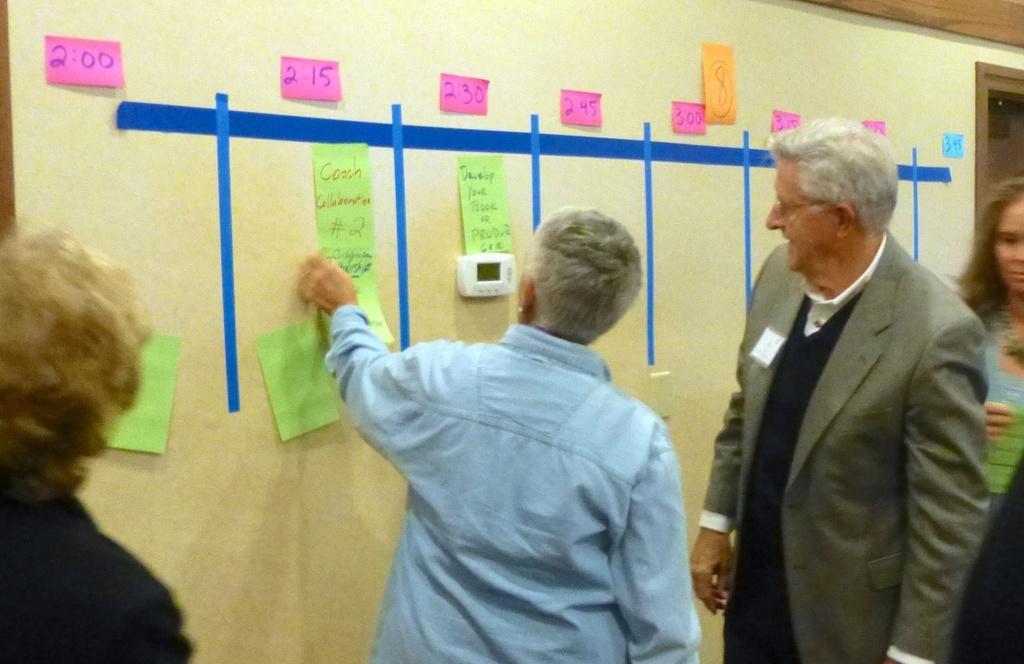Could you give a brief overview of what you see in this image? In this picture we can see people standing and looking at the papers stuck on the wall. 